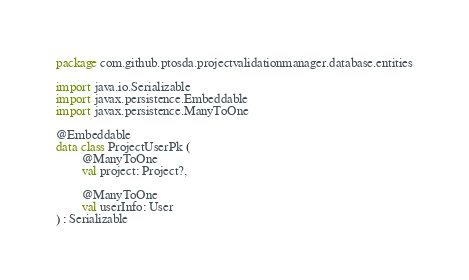Convert code to text. <code><loc_0><loc_0><loc_500><loc_500><_Kotlin_>package com.github.ptosda.projectvalidationmanager.database.entities

import java.io.Serializable
import javax.persistence.Embeddable
import javax.persistence.ManyToOne

@Embeddable
data class ProjectUserPk (
        @ManyToOne
        val project: Project?,

        @ManyToOne
        val userInfo: User
) : Serializable
</code> 